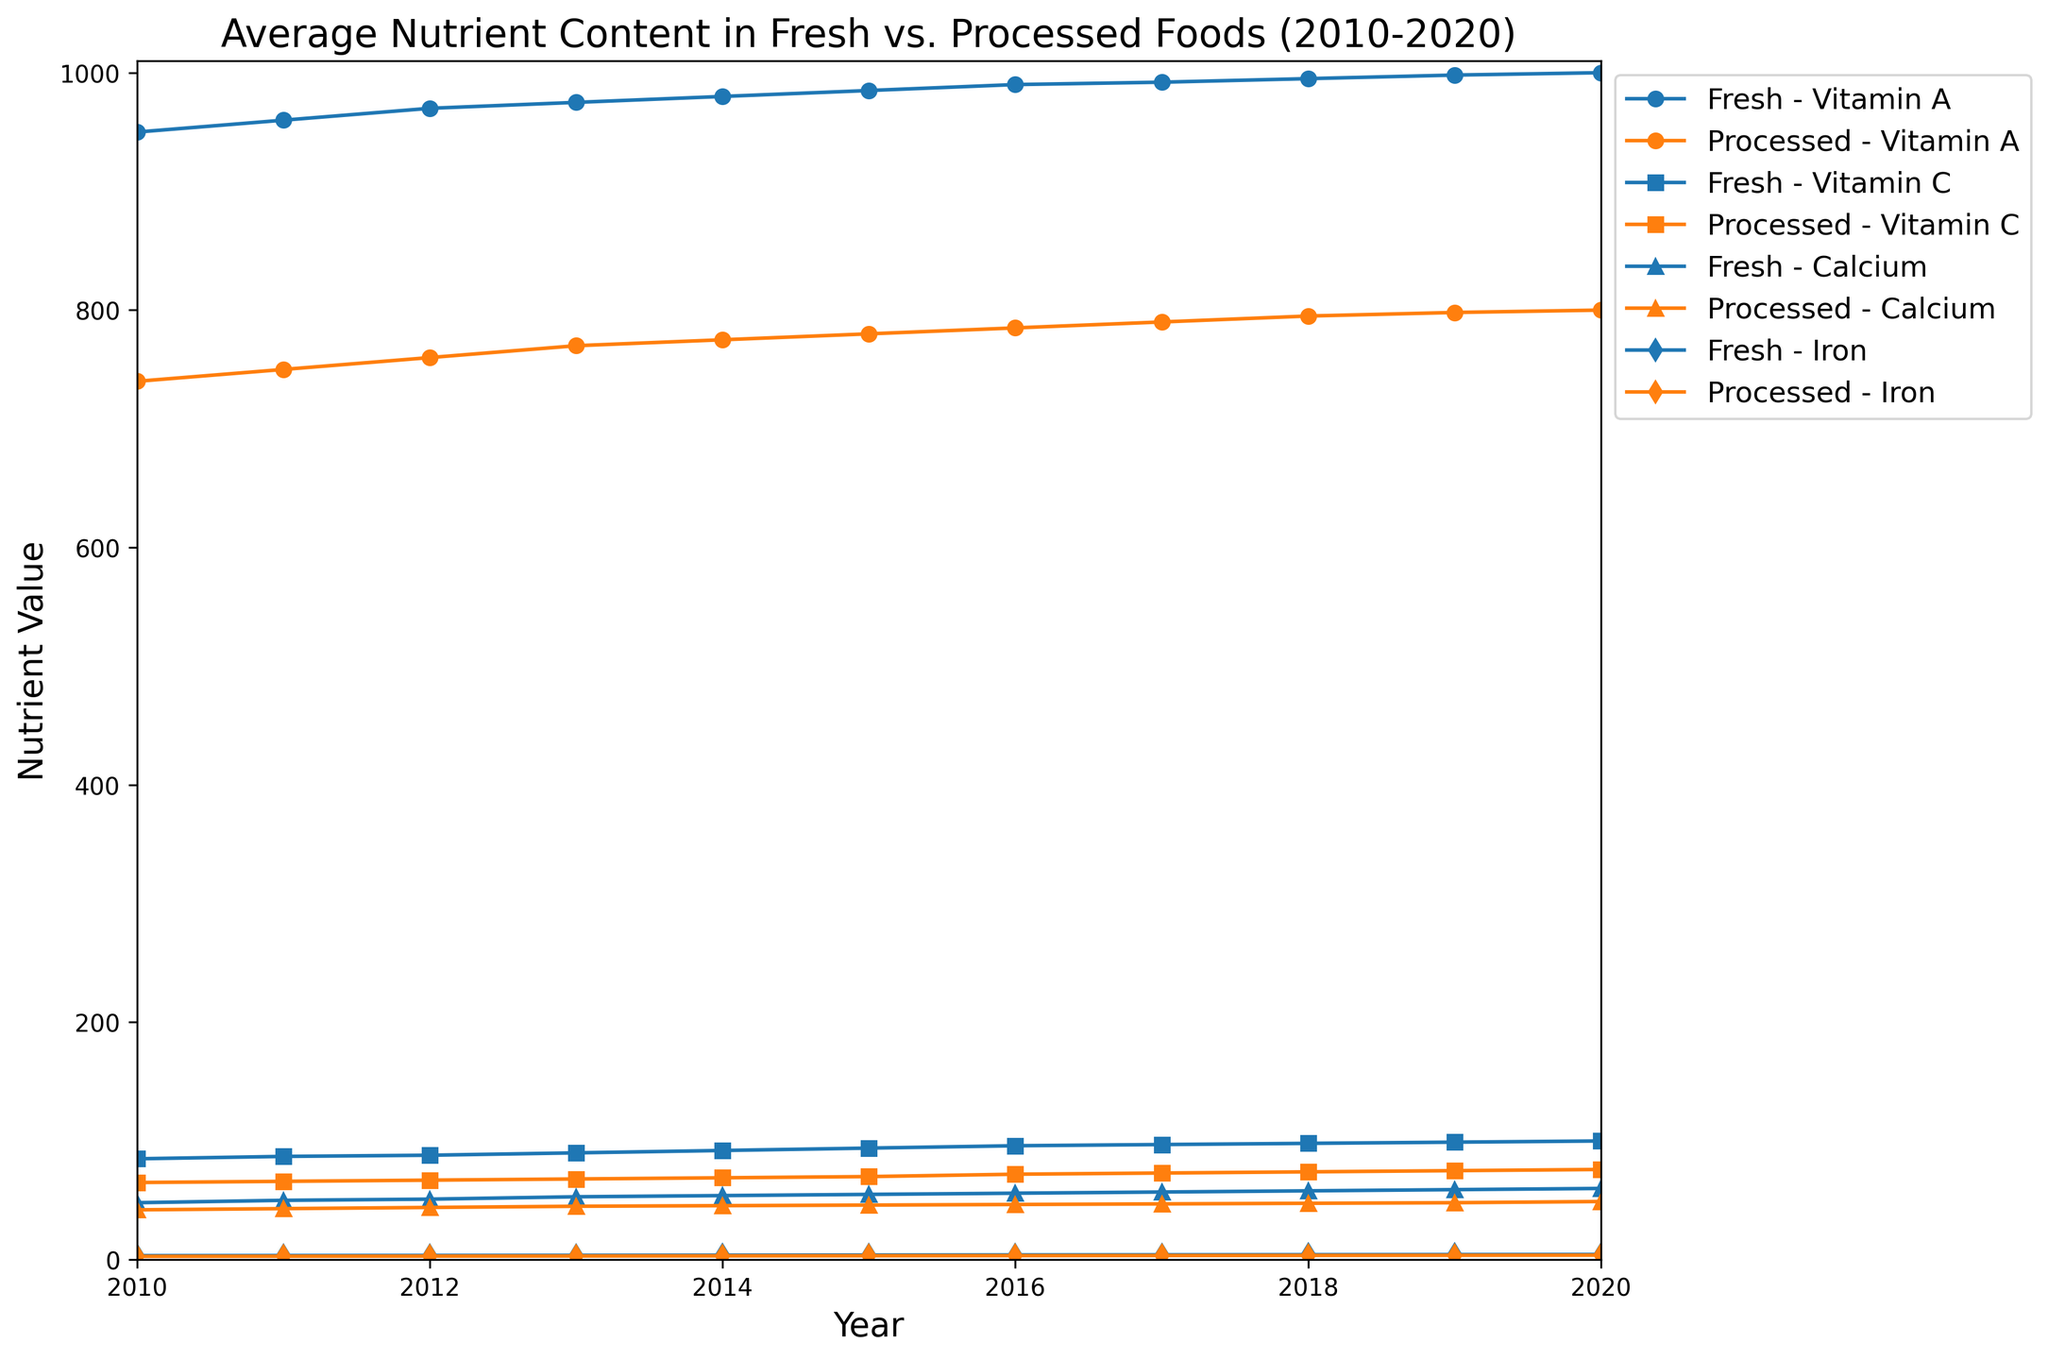What is the difference in Vitamin A content between Fresh and Processed foods in 2020? To find the difference in Vitamin A content between Fresh and Processed foods in 2020, look at the values for Vitamin A in both categories for the year 2020. The Vitamin A content in Fresh foods is 1000, while in Processed foods it is 800. So, the difference is 1000 - 800 = 200.
Answer: 200 How does the trend of Iron content in Fresh foods compare to that in Processed foods from 2010 to 2020? To compare the trends, observe the line patterns of Iron content for Fresh and Processed foods over the years. The Iron content in Fresh foods shows a consistent increase from 3.4 in 2010 to 4.4 in 2020. Similarly, Processed foods also show a slight increase from 2.8 in 2010 to 3.8 in 2020. Both show an upward trend, but the increase is more pronounced in Fresh foods.
Answer: Upward trend in both, more pronounced in Fresh Which nutrient shows the greatest difference in value between Fresh and Processed foods in 2015? Look at the values for each nutrient in Fresh and Processed foods for the year 2015. Calculate the differences: Vitamin A: 985 - 780 = 205, Vitamin C: 94 - 70 = 24, Calcium: 55 - 46 = 9, Iron: 3.9 - 3.3 = 0.6. The greatest difference is in Vitamin A with a difference of 205.
Answer: Vitamin A What is the average value of Calcium content in Fresh foods from 2010 to 2020? To calculate the average Calcium content in Fresh foods, sum the Calcium values from 2010 to 2020 and divide by the number of years. Sum: 48 + 50 + 51 + 53 + 54 + 55 + 56 + 57 + 58 + 59 + 60 = 551. Number of years: 11. So, the average is 551 / 11 = 50.1.
Answer: 50.1 In which year did the Vitamin C content in Fresh foods surpass 90 for the first time? To find the year when Vitamin C content in Fresh foods surpassed 90, look for the first year with a value greater than 90. The values are 85 (2010), 87 (2011), 88 (2012), 90 (2013), 92 (2014), so the first year it surpasses 90 is 2014.
Answer: 2014 Which category and nutrient combination shows the least increase in content from 2010 to 2020? Calculate the increase for each category and nutrient combination from 2010 to 2020. Fresh Vitamin A: 1000 - 950 = 50, Fresh Vitamin C: 100 - 85 = 15, Fresh Calcium: 60 - 48 = 12, Fresh Iron: 4.4 - 3.4 = 1.0, Processed Vitamin A: 800 - 740 = 60, Processed Vitamin C: 76 - 65 = 11, Processed Calcium: 49 - 42 = 7, Processed Iron: 3.8 - 2.8 = 1.0. The least increase is in Fresh Iron and Processed Iron, both with a 1.0 increase.
Answer: Fresh Iron, Processed Iron What is the combined average value of Vitamin C content in Fresh and Processed foods in 2018? Calculate the average Vitamin C content for Fresh and Processed foods in 2018 separately, then find their combined average. Fresh Vitamin C: 98, Processed Vitamin C: 74. Combined average = (98 + 74) / 2 = 86.
Answer: 86 How does the Calcium content in Processed foods in 2020 compare to that in 2010? Look at the Calcium content values for Processed foods in 2010 and 2020. In 2010, it is 42 and in 2020 it is 49. To compare, calculate the difference: 49 - 42 = 7. The Calcium content increased by 7 units.
Answer: Increased by 7 units 